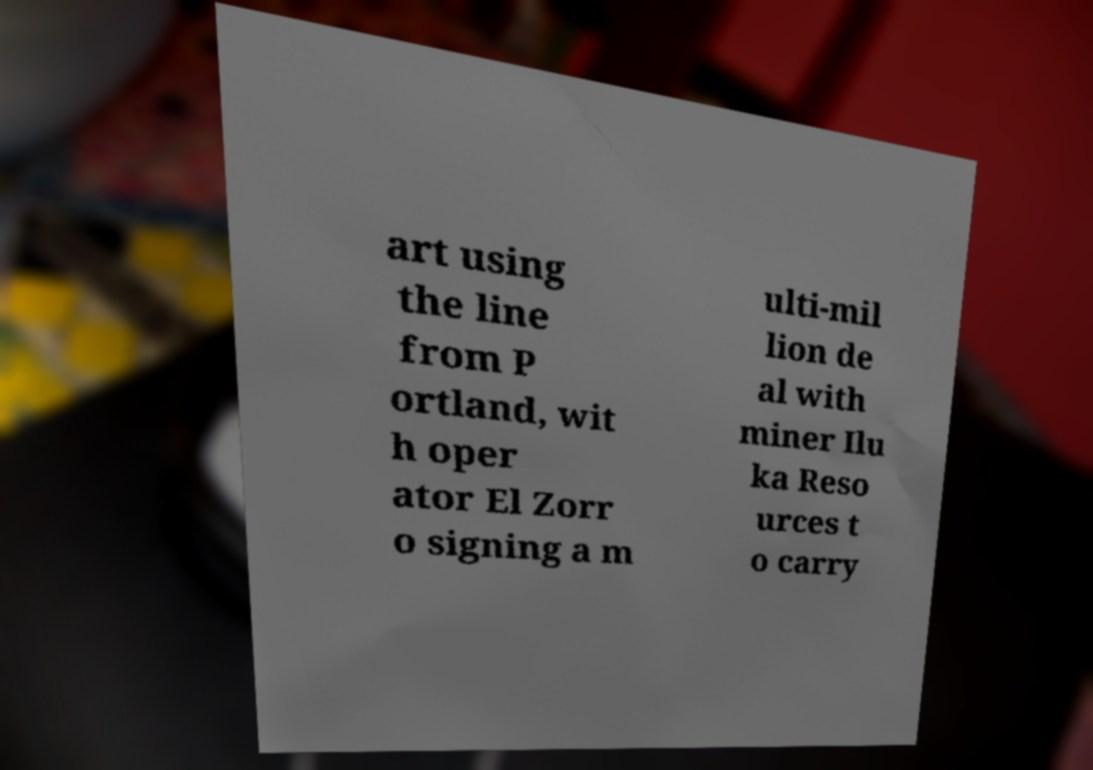What messages or text are displayed in this image? I need them in a readable, typed format. art using the line from P ortland, wit h oper ator El Zorr o signing a m ulti-mil lion de al with miner Ilu ka Reso urces t o carry 